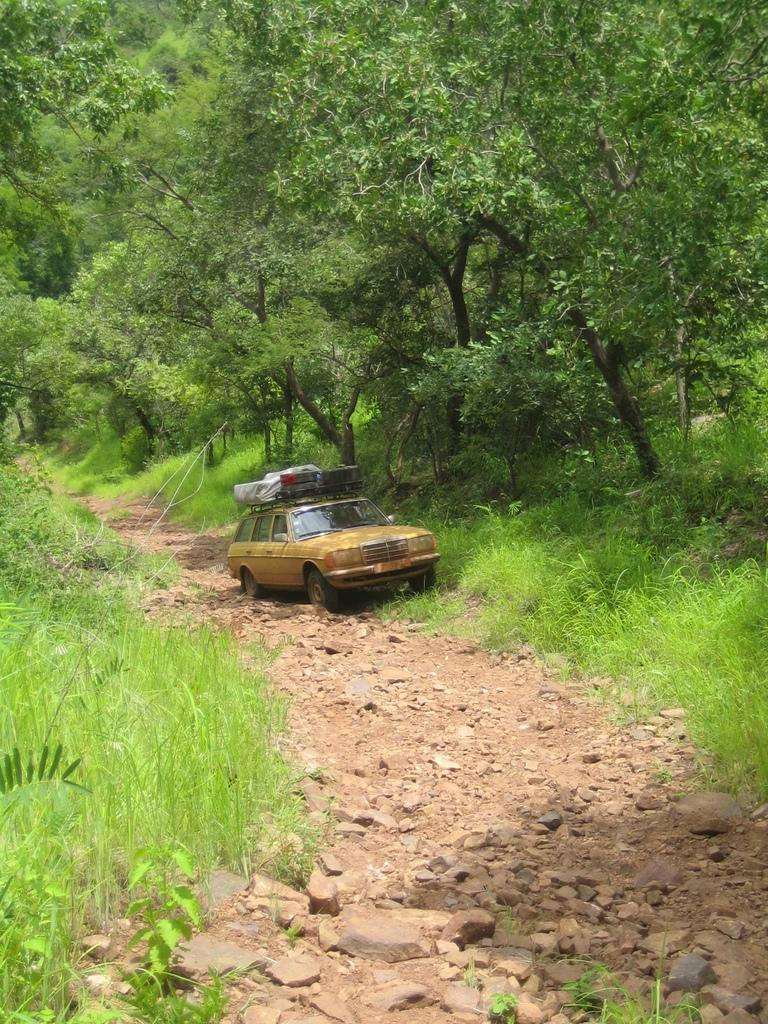What is on top of the car in the image? There is baggage on the car. What can be seen near the car in the image? There are plants and trees beside the car. What type of beast is hiding behind the trees in the image? There is no beast present in the image; only the car, baggage, plants, and trees are visible. 